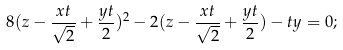Convert formula to latex. <formula><loc_0><loc_0><loc_500><loc_500>8 ( z - \frac { x t } { \sqrt { 2 } } + \frac { y t } { 2 } ) ^ { 2 } - 2 ( z - \frac { x t } { \sqrt { 2 } } + \frac { y t } { 2 } ) - t y = 0 ;</formula> 